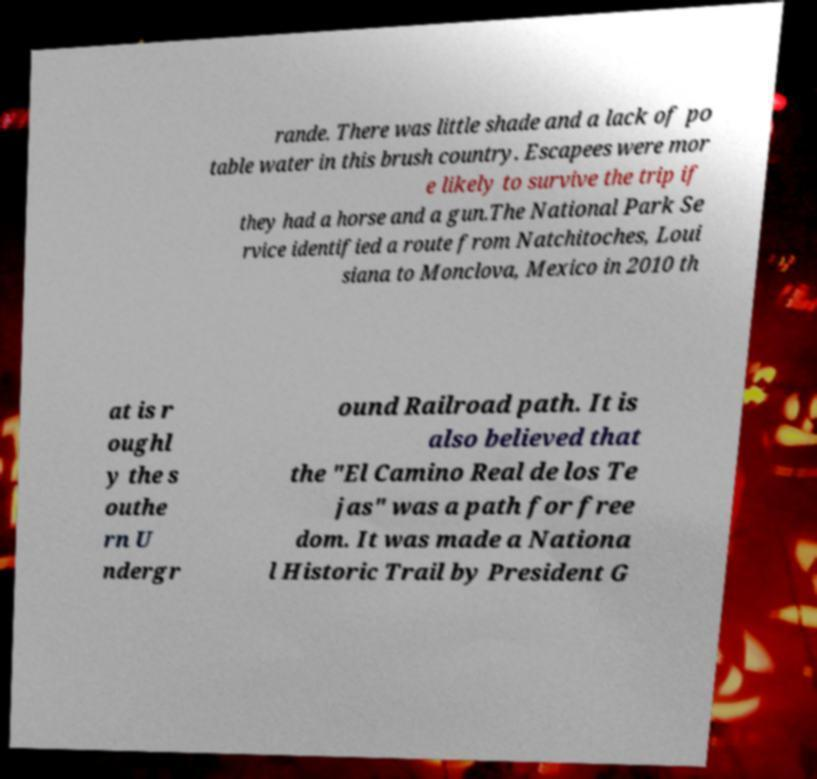Can you accurately transcribe the text from the provided image for me? rande. There was little shade and a lack of po table water in this brush country. Escapees were mor e likely to survive the trip if they had a horse and a gun.The National Park Se rvice identified a route from Natchitoches, Loui siana to Monclova, Mexico in 2010 th at is r oughl y the s outhe rn U ndergr ound Railroad path. It is also believed that the "El Camino Real de los Te jas" was a path for free dom. It was made a Nationa l Historic Trail by President G 